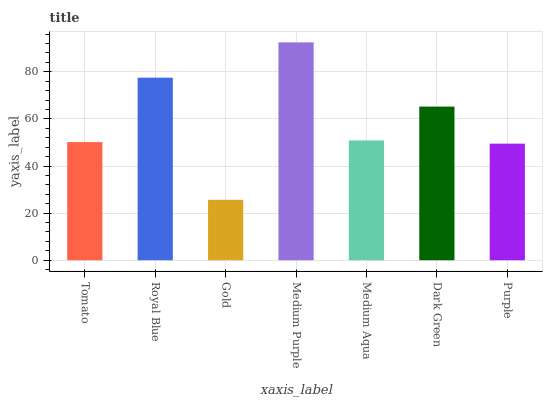Is Gold the minimum?
Answer yes or no. Yes. Is Medium Purple the maximum?
Answer yes or no. Yes. Is Royal Blue the minimum?
Answer yes or no. No. Is Royal Blue the maximum?
Answer yes or no. No. Is Royal Blue greater than Tomato?
Answer yes or no. Yes. Is Tomato less than Royal Blue?
Answer yes or no. Yes. Is Tomato greater than Royal Blue?
Answer yes or no. No. Is Royal Blue less than Tomato?
Answer yes or no. No. Is Medium Aqua the high median?
Answer yes or no. Yes. Is Medium Aqua the low median?
Answer yes or no. Yes. Is Tomato the high median?
Answer yes or no. No. Is Tomato the low median?
Answer yes or no. No. 